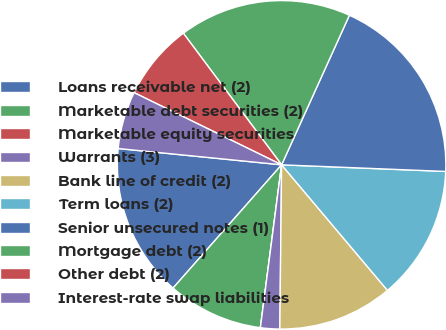Convert chart to OTSL. <chart><loc_0><loc_0><loc_500><loc_500><pie_chart><fcel>Loans receivable net (2)<fcel>Marketable debt securities (2)<fcel>Marketable equity securities<fcel>Warrants (3)<fcel>Bank line of credit (2)<fcel>Term loans (2)<fcel>Senior unsecured notes (1)<fcel>Mortgage debt (2)<fcel>Other debt (2)<fcel>Interest-rate swap liabilities<nl><fcel>15.09%<fcel>9.43%<fcel>0.0%<fcel>1.89%<fcel>11.32%<fcel>13.21%<fcel>18.87%<fcel>16.98%<fcel>7.55%<fcel>5.66%<nl></chart> 